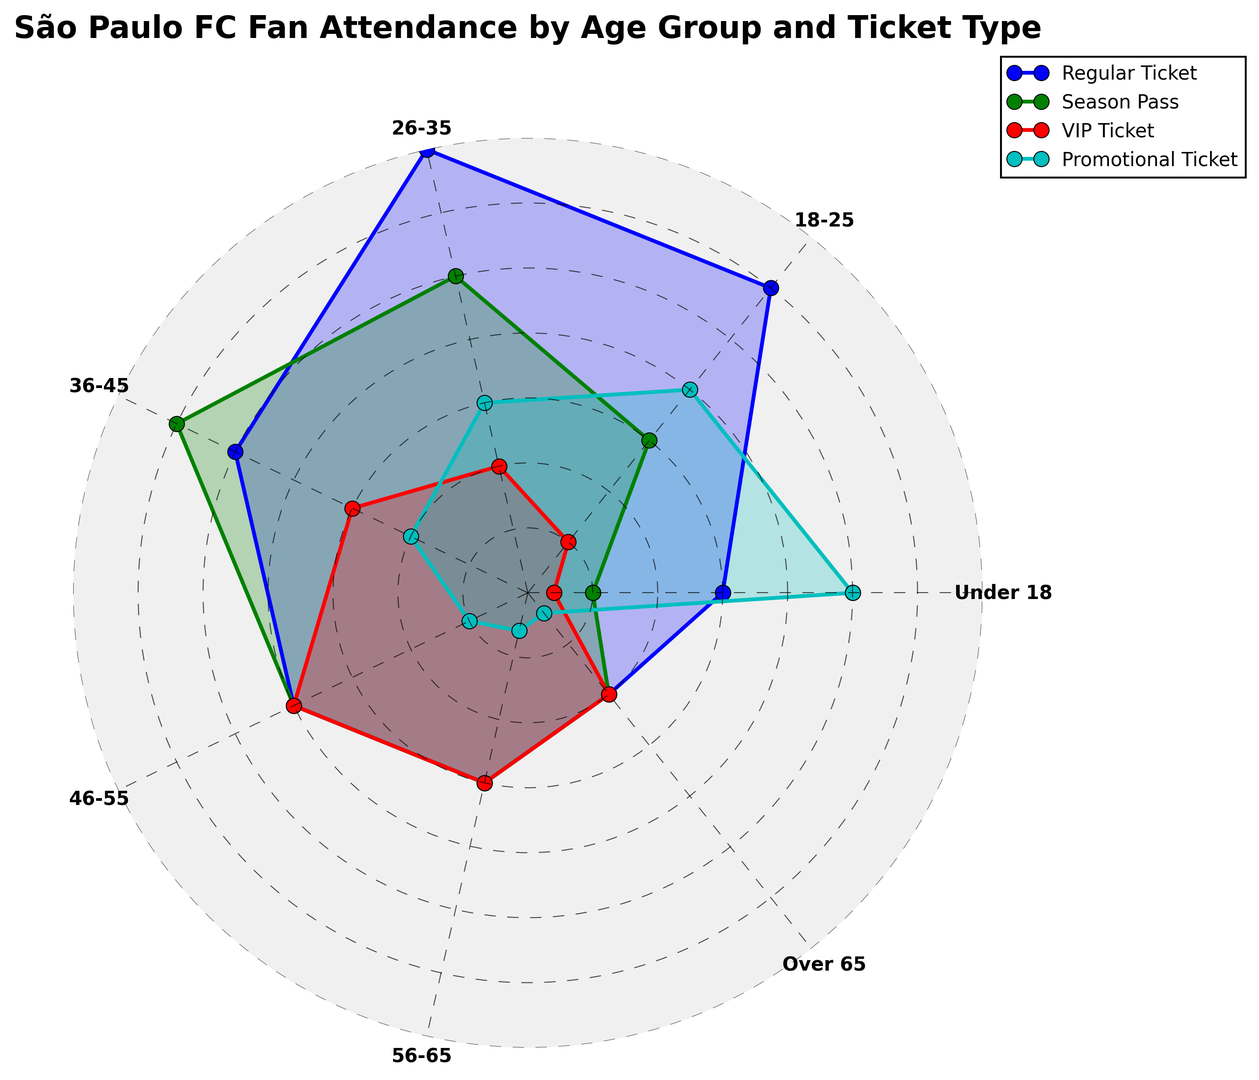What's the most purchased ticket type by the 26-35 age group? By observing the figure, we see that the line connected to the "26-35" category is highest for the "Regular Ticket," indicating it has the largest value for this group.
Answer: Regular Ticket Which age group has the least number of VIP Ticket purchases? We find the smallest point on the VIP Ticket line, which corresponds to the "Over 65" category, indicating it has the lowest number of VIP Ticket purchases.
Answer: Over 65 Compare the number of Season Pass purchases between the 18-25 and 36-45 age groups. Which is higher? By observing the lengths of the lines, the 36-45 age group has a longer line segment than the 18-25 age group on the "Season Pass" line, indicating it has a higher number of Season Pass purchases.
Answer: 36-45 Calculate the average number of Regular Ticket purchases across all age groups. To get the average, we sum up the Regular Ticket numbers (15+30+35+25+20+15+10) = 150. Then, we divide by the number of age groups, which is 7. 150/7 ≈ 21.43
Answer: 21.43 Which ticket type has the most significant attendance drop from the 26-35 to the 46-55 age group? We compare the differences between the values of the ticket types for the 26-35 and 46-55 groups. The largest drop is for "Promotional Ticket" from 15 to 5, a difference of 10.
Answer: Promotional Ticket Does any age group have an equal number of purchases across two or more ticket types? The "Over 65" age group has equal numbers (10) for Regular Ticket, Season Pass, and VIP Ticket.
Answer: Over 65 